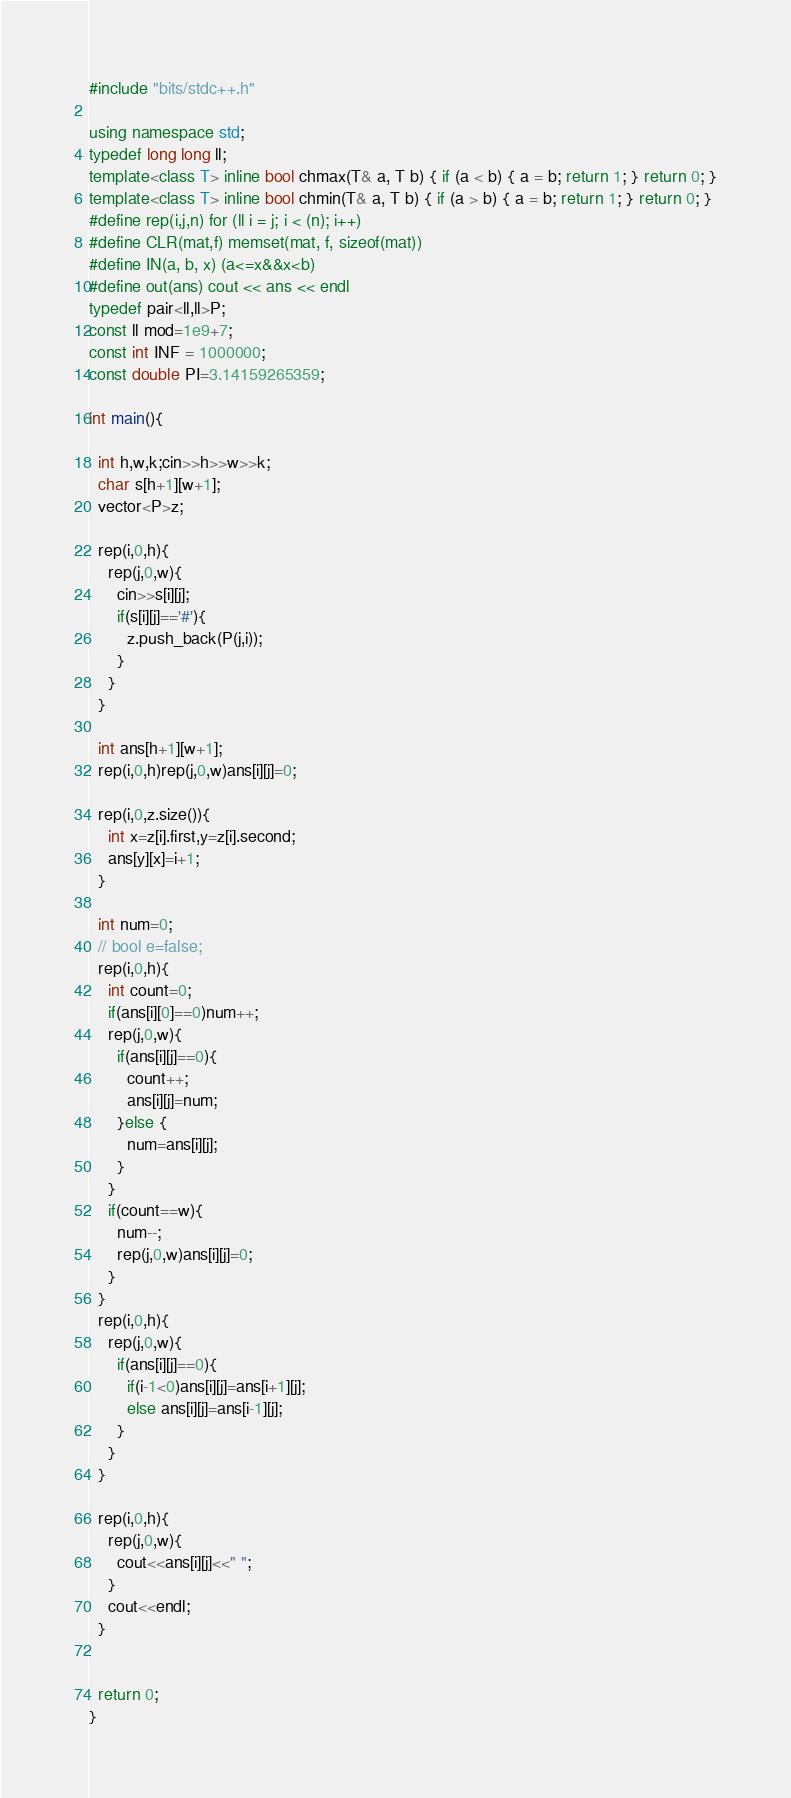<code> <loc_0><loc_0><loc_500><loc_500><_C++_>#include "bits/stdc++.h"

using namespace std;
typedef long long ll;
template<class T> inline bool chmax(T& a, T b) { if (a < b) { a = b; return 1; } return 0; }
template<class T> inline bool chmin(T& a, T b) { if (a > b) { a = b; return 1; } return 0; }
#define rep(i,j,n) for (ll i = j; i < (n); i++)
#define CLR(mat,f) memset(mat, f, sizeof(mat))
#define IN(a, b, x) (a<=x&&x<b)
#define out(ans) cout << ans << endl
typedef pair<ll,ll>P;
const ll mod=1e9+7;
const int INF = 1000000;
const double PI=3.14159265359;

int main(){

  int h,w,k;cin>>h>>w>>k;
  char s[h+1][w+1];
  vector<P>z;

  rep(i,0,h){
    rep(j,0,w){
      cin>>s[i][j];
      if(s[i][j]=='#'){
        z.push_back(P(j,i));
      }
    }
  }

  int ans[h+1][w+1];
  rep(i,0,h)rep(j,0,w)ans[i][j]=0;

  rep(i,0,z.size()){
    int x=z[i].first,y=z[i].second;
    ans[y][x]=i+1;
  }

  int num=0;
  // bool e=false;
  rep(i,0,h){
    int count=0;
    if(ans[i][0]==0)num++;
    rep(j,0,w){
      if(ans[i][j]==0){
        count++;
        ans[i][j]=num;
      }else {
        num=ans[i][j];
      }
    }
    if(count==w){
      num--;
      rep(j,0,w)ans[i][j]=0;
    }
  }
  rep(i,0,h){
    rep(j,0,w){
      if(ans[i][j]==0){
        if(i-1<0)ans[i][j]=ans[i+1][j];
        else ans[i][j]=ans[i-1][j];
      }
    }
  }

  rep(i,0,h){
    rep(j,0,w){
      cout<<ans[i][j]<<" ";
    }
    cout<<endl;
  }


  return 0;
}
</code> 